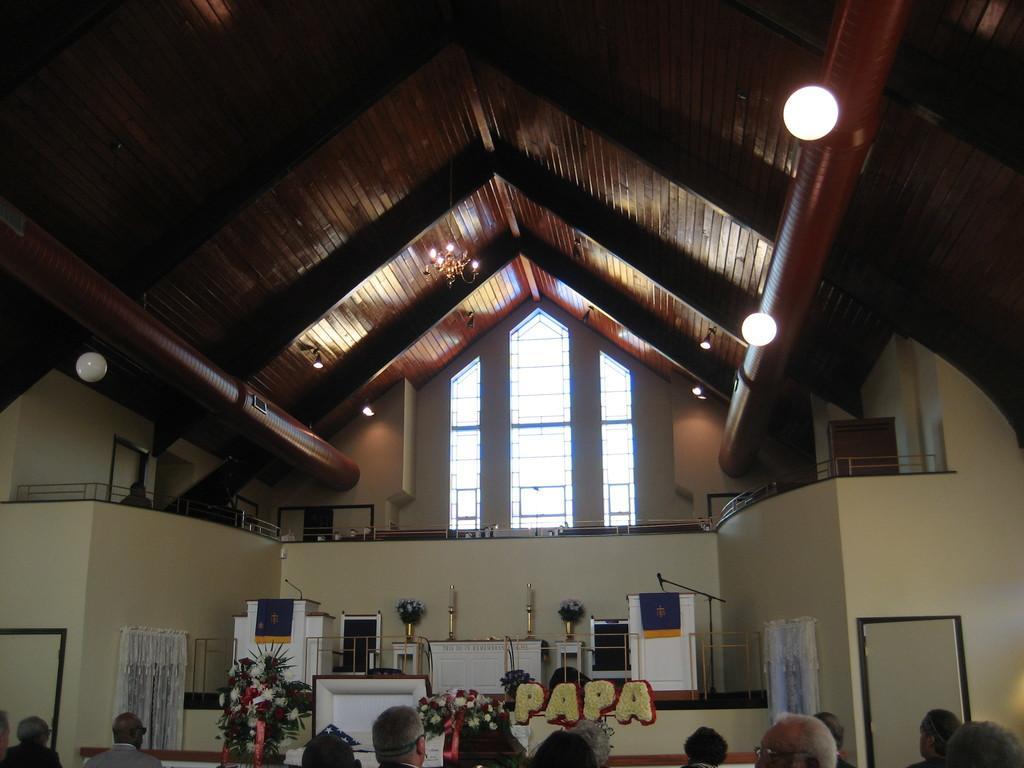In one or two sentences, can you explain what this image depicts? In this picture, we can see a few people and the w interior view of a house where we can see some podiums, flower pots, microphones, text craft, stage and a roof top with lights and a wall with doors and fencing, glass windows. 